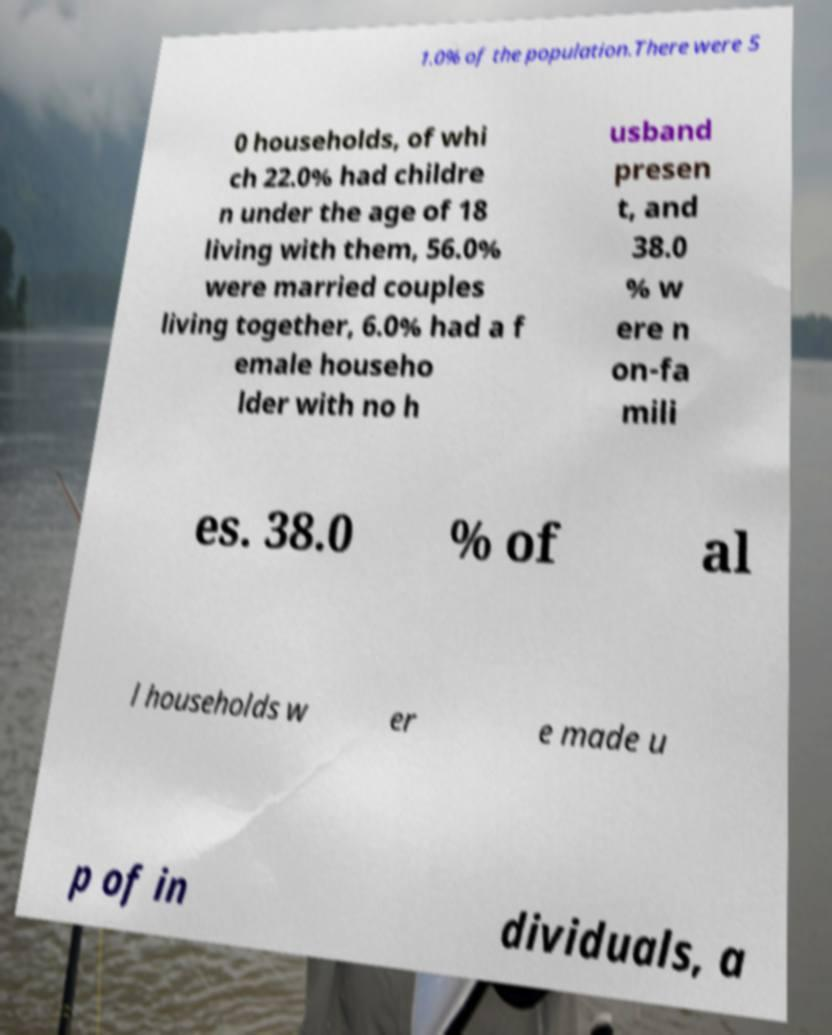I need the written content from this picture converted into text. Can you do that? 1.0% of the population.There were 5 0 households, of whi ch 22.0% had childre n under the age of 18 living with them, 56.0% were married couples living together, 6.0% had a f emale househo lder with no h usband presen t, and 38.0 % w ere n on-fa mili es. 38.0 % of al l households w er e made u p of in dividuals, a 